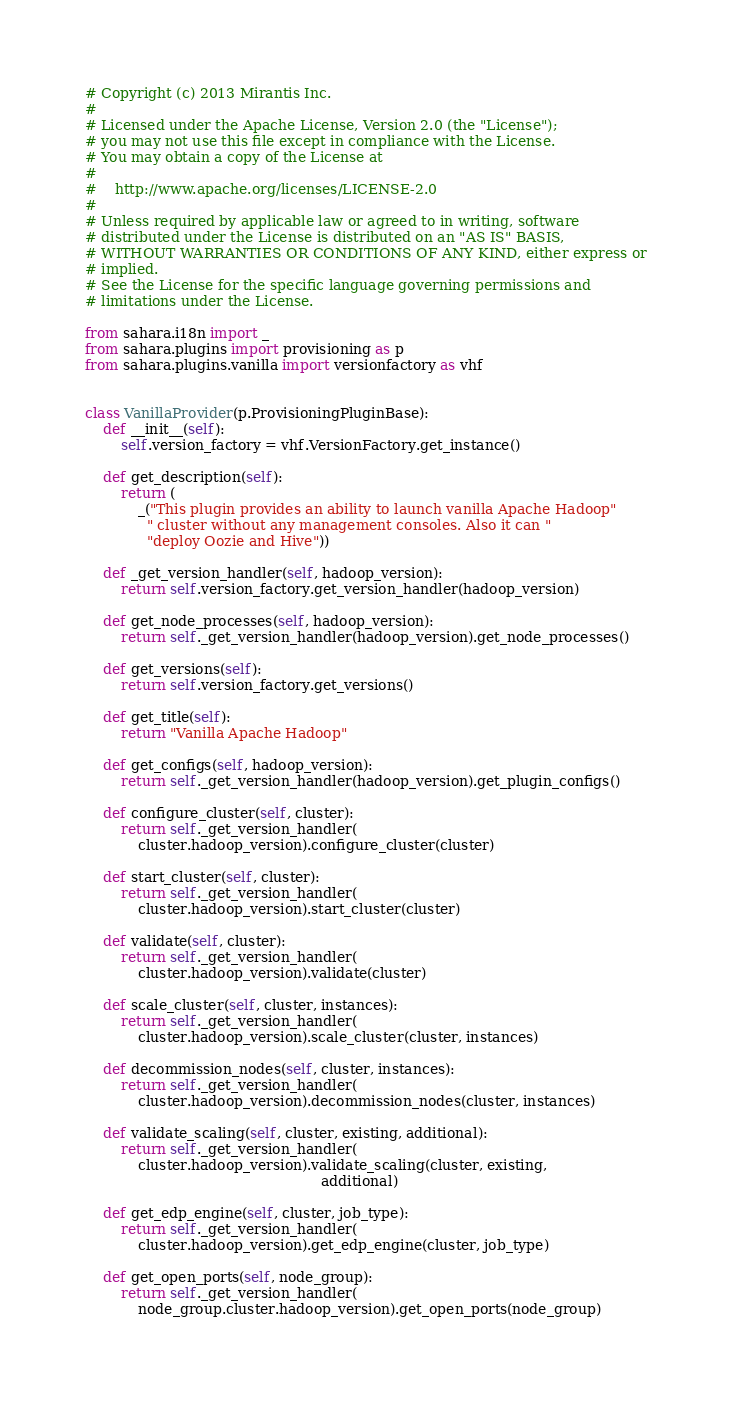<code> <loc_0><loc_0><loc_500><loc_500><_Python_># Copyright (c) 2013 Mirantis Inc.
#
# Licensed under the Apache License, Version 2.0 (the "License");
# you may not use this file except in compliance with the License.
# You may obtain a copy of the License at
#
#    http://www.apache.org/licenses/LICENSE-2.0
#
# Unless required by applicable law or agreed to in writing, software
# distributed under the License is distributed on an "AS IS" BASIS,
# WITHOUT WARRANTIES OR CONDITIONS OF ANY KIND, either express or
# implied.
# See the License for the specific language governing permissions and
# limitations under the License.

from sahara.i18n import _
from sahara.plugins import provisioning as p
from sahara.plugins.vanilla import versionfactory as vhf


class VanillaProvider(p.ProvisioningPluginBase):
    def __init__(self):
        self.version_factory = vhf.VersionFactory.get_instance()

    def get_description(self):
        return (
            _("This plugin provides an ability to launch vanilla Apache Hadoop"
              " cluster without any management consoles. Also it can "
              "deploy Oozie and Hive"))

    def _get_version_handler(self, hadoop_version):
        return self.version_factory.get_version_handler(hadoop_version)

    def get_node_processes(self, hadoop_version):
        return self._get_version_handler(hadoop_version).get_node_processes()

    def get_versions(self):
        return self.version_factory.get_versions()

    def get_title(self):
        return "Vanilla Apache Hadoop"

    def get_configs(self, hadoop_version):
        return self._get_version_handler(hadoop_version).get_plugin_configs()

    def configure_cluster(self, cluster):
        return self._get_version_handler(
            cluster.hadoop_version).configure_cluster(cluster)

    def start_cluster(self, cluster):
        return self._get_version_handler(
            cluster.hadoop_version).start_cluster(cluster)

    def validate(self, cluster):
        return self._get_version_handler(
            cluster.hadoop_version).validate(cluster)

    def scale_cluster(self, cluster, instances):
        return self._get_version_handler(
            cluster.hadoop_version).scale_cluster(cluster, instances)

    def decommission_nodes(self, cluster, instances):
        return self._get_version_handler(
            cluster.hadoop_version).decommission_nodes(cluster, instances)

    def validate_scaling(self, cluster, existing, additional):
        return self._get_version_handler(
            cluster.hadoop_version).validate_scaling(cluster, existing,
                                                     additional)

    def get_edp_engine(self, cluster, job_type):
        return self._get_version_handler(
            cluster.hadoop_version).get_edp_engine(cluster, job_type)

    def get_open_ports(self, node_group):
        return self._get_version_handler(
            node_group.cluster.hadoop_version).get_open_ports(node_group)
</code> 